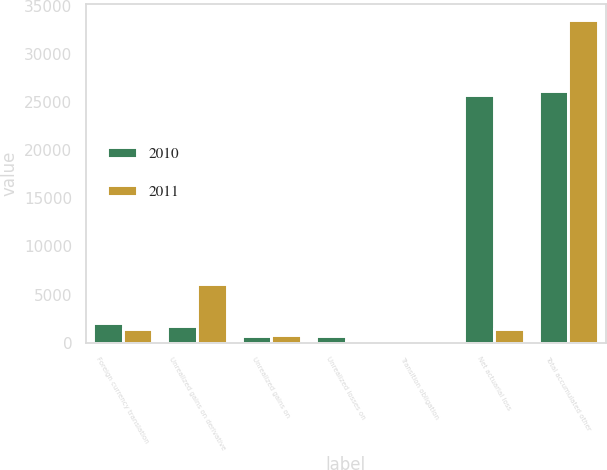Convert chart. <chart><loc_0><loc_0><loc_500><loc_500><stacked_bar_chart><ecel><fcel>Foreign currency translation<fcel>Unrealized gains on derivative<fcel>Unrealized gains on<fcel>Unrealized losses on<fcel>Transition obligation<fcel>Net actuarial loss<fcel>Total accumulated other<nl><fcel>2010<fcel>2038<fcel>1687<fcel>695<fcel>641<fcel>117<fcel>25755<fcel>26169<nl><fcel>2011<fcel>1391<fcel>6133<fcel>822<fcel>191<fcel>129<fcel>1391<fcel>33595<nl></chart> 